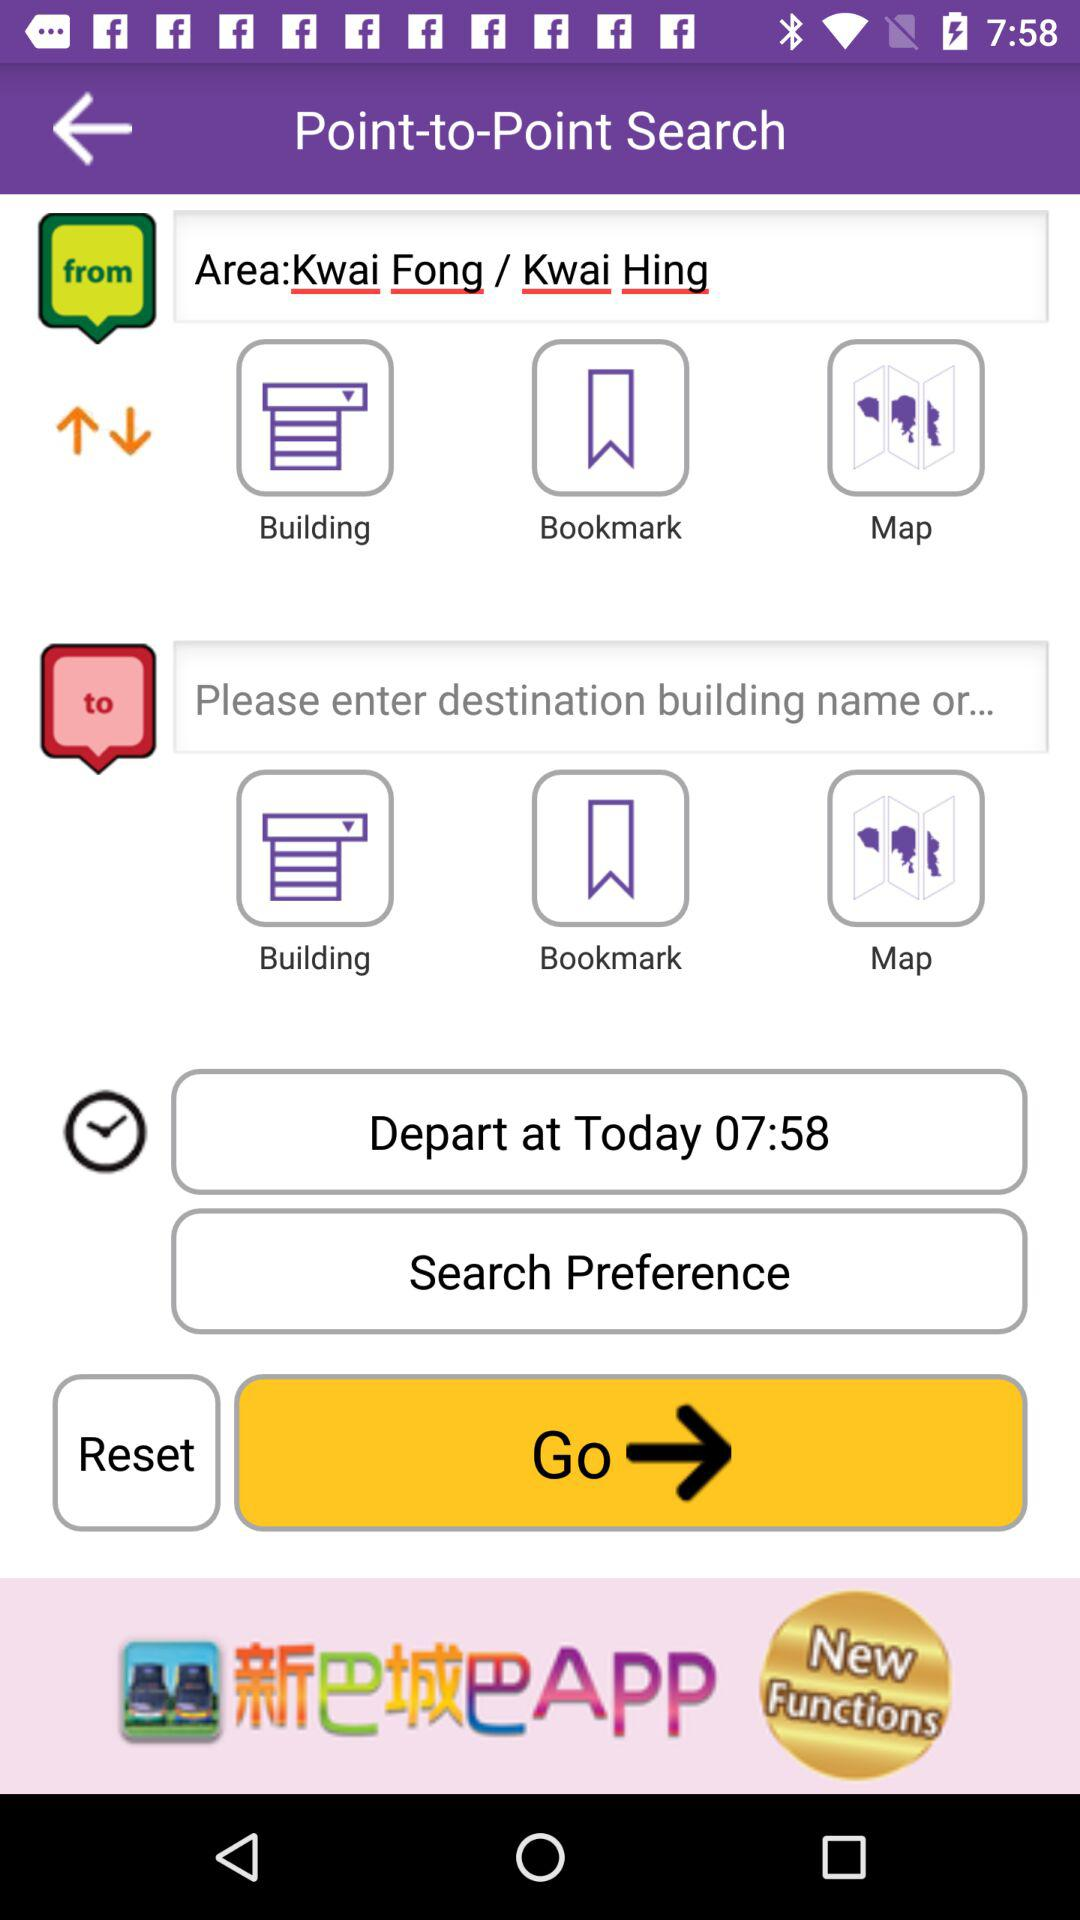What is the departure location? The departure location is Kwai Fong or Kwai Hing. 